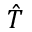Convert formula to latex. <formula><loc_0><loc_0><loc_500><loc_500>\hat { T }</formula> 